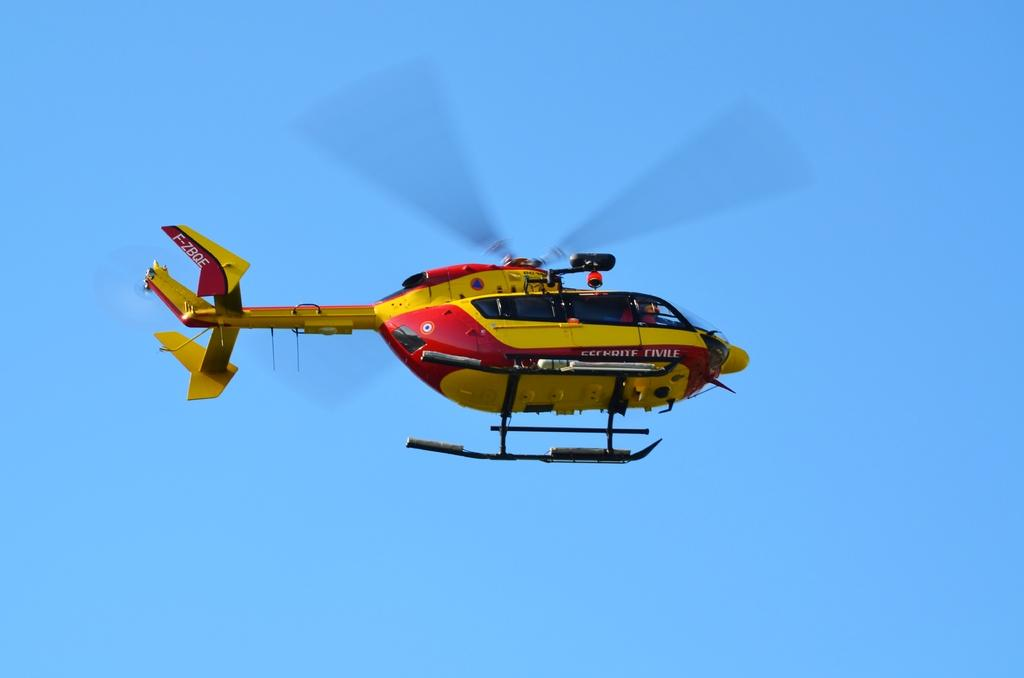What is the main subject of the image? The main subject of the image is a helicopter. What is the helicopter doing in the image? The helicopter is flying in the sky. Where is the rake being used in the image? There is no rake present in the image. Can you see any ghosts in the image? There are no ghosts present in the image. 